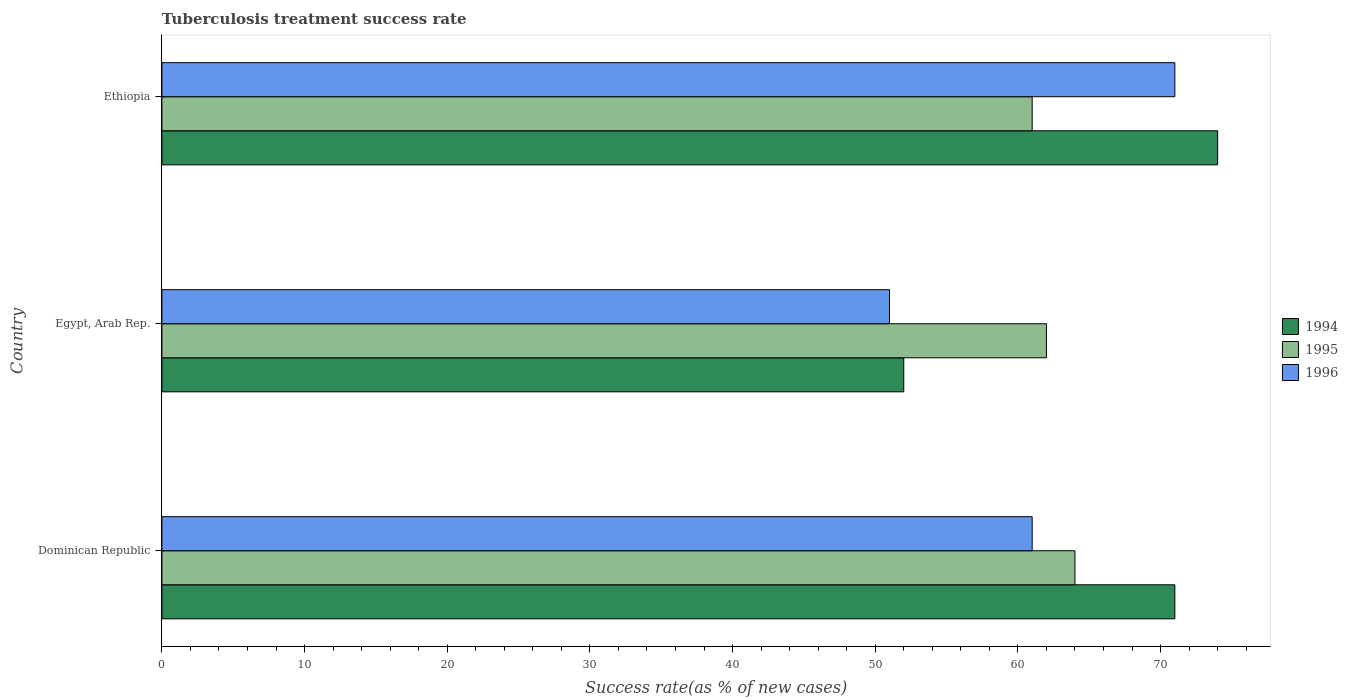How many different coloured bars are there?
Offer a very short reply. 3. How many groups of bars are there?
Offer a very short reply. 3. Are the number of bars on each tick of the Y-axis equal?
Your response must be concise. Yes. How many bars are there on the 3rd tick from the top?
Provide a succinct answer. 3. What is the label of the 1st group of bars from the top?
Give a very brief answer. Ethiopia. In how many cases, is the number of bars for a given country not equal to the number of legend labels?
Your response must be concise. 0. Across all countries, what is the maximum tuberculosis treatment success rate in 1994?
Offer a very short reply. 74. Across all countries, what is the minimum tuberculosis treatment success rate in 1996?
Provide a short and direct response. 51. In which country was the tuberculosis treatment success rate in 1995 maximum?
Make the answer very short. Dominican Republic. In which country was the tuberculosis treatment success rate in 1995 minimum?
Keep it short and to the point. Ethiopia. What is the total tuberculosis treatment success rate in 1995 in the graph?
Give a very brief answer. 187. What is the difference between the tuberculosis treatment success rate in 1994 in Ethiopia and the tuberculosis treatment success rate in 1995 in Egypt, Arab Rep.?
Your answer should be very brief. 12. What is the average tuberculosis treatment success rate in 1994 per country?
Your response must be concise. 65.67. What is the ratio of the tuberculosis treatment success rate in 1996 in Egypt, Arab Rep. to that in Ethiopia?
Your response must be concise. 0.72. Is the difference between the tuberculosis treatment success rate in 1995 in Dominican Republic and Ethiopia greater than the difference between the tuberculosis treatment success rate in 1996 in Dominican Republic and Ethiopia?
Your response must be concise. Yes. Is the sum of the tuberculosis treatment success rate in 1994 in Egypt, Arab Rep. and Ethiopia greater than the maximum tuberculosis treatment success rate in 1996 across all countries?
Provide a short and direct response. Yes. What does the 3rd bar from the bottom in Egypt, Arab Rep. represents?
Your response must be concise. 1996. Is it the case that in every country, the sum of the tuberculosis treatment success rate in 1995 and tuberculosis treatment success rate in 1996 is greater than the tuberculosis treatment success rate in 1994?
Offer a very short reply. Yes. How many countries are there in the graph?
Offer a terse response. 3. Are the values on the major ticks of X-axis written in scientific E-notation?
Provide a succinct answer. No. Does the graph contain any zero values?
Your response must be concise. No. How many legend labels are there?
Your response must be concise. 3. What is the title of the graph?
Provide a succinct answer. Tuberculosis treatment success rate. What is the label or title of the X-axis?
Make the answer very short. Success rate(as % of new cases). What is the label or title of the Y-axis?
Ensure brevity in your answer.  Country. What is the Success rate(as % of new cases) of 1995 in Egypt, Arab Rep.?
Offer a very short reply. 62. What is the Success rate(as % of new cases) of 1995 in Ethiopia?
Offer a terse response. 61. What is the Success rate(as % of new cases) in 1996 in Ethiopia?
Your response must be concise. 71. Across all countries, what is the maximum Success rate(as % of new cases) of 1995?
Your answer should be very brief. 64. Across all countries, what is the maximum Success rate(as % of new cases) in 1996?
Provide a succinct answer. 71. Across all countries, what is the minimum Success rate(as % of new cases) of 1995?
Provide a succinct answer. 61. Across all countries, what is the minimum Success rate(as % of new cases) in 1996?
Keep it short and to the point. 51. What is the total Success rate(as % of new cases) of 1994 in the graph?
Provide a succinct answer. 197. What is the total Success rate(as % of new cases) of 1995 in the graph?
Keep it short and to the point. 187. What is the total Success rate(as % of new cases) of 1996 in the graph?
Your response must be concise. 183. What is the difference between the Success rate(as % of new cases) of 1996 in Dominican Republic and that in Egypt, Arab Rep.?
Provide a short and direct response. 10. What is the difference between the Success rate(as % of new cases) of 1996 in Dominican Republic and that in Ethiopia?
Offer a very short reply. -10. What is the difference between the Success rate(as % of new cases) in 1994 in Egypt, Arab Rep. and that in Ethiopia?
Offer a very short reply. -22. What is the difference between the Success rate(as % of new cases) in 1995 in Egypt, Arab Rep. and that in Ethiopia?
Give a very brief answer. 1. What is the difference between the Success rate(as % of new cases) in 1996 in Egypt, Arab Rep. and that in Ethiopia?
Ensure brevity in your answer.  -20. What is the difference between the Success rate(as % of new cases) in 1994 in Dominican Republic and the Success rate(as % of new cases) in 1996 in Egypt, Arab Rep.?
Your response must be concise. 20. What is the difference between the Success rate(as % of new cases) in 1995 in Dominican Republic and the Success rate(as % of new cases) in 1996 in Egypt, Arab Rep.?
Ensure brevity in your answer.  13. What is the difference between the Success rate(as % of new cases) in 1994 in Dominican Republic and the Success rate(as % of new cases) in 1995 in Ethiopia?
Your answer should be compact. 10. What is the difference between the Success rate(as % of new cases) in 1994 in Egypt, Arab Rep. and the Success rate(as % of new cases) in 1995 in Ethiopia?
Your response must be concise. -9. What is the difference between the Success rate(as % of new cases) of 1995 in Egypt, Arab Rep. and the Success rate(as % of new cases) of 1996 in Ethiopia?
Your answer should be compact. -9. What is the average Success rate(as % of new cases) in 1994 per country?
Give a very brief answer. 65.67. What is the average Success rate(as % of new cases) in 1995 per country?
Offer a terse response. 62.33. What is the average Success rate(as % of new cases) in 1996 per country?
Your answer should be very brief. 61. What is the difference between the Success rate(as % of new cases) in 1994 and Success rate(as % of new cases) in 1996 in Dominican Republic?
Offer a very short reply. 10. What is the difference between the Success rate(as % of new cases) of 1994 and Success rate(as % of new cases) of 1995 in Egypt, Arab Rep.?
Your answer should be compact. -10. What is the difference between the Success rate(as % of new cases) in 1995 and Success rate(as % of new cases) in 1996 in Egypt, Arab Rep.?
Provide a succinct answer. 11. What is the difference between the Success rate(as % of new cases) in 1994 and Success rate(as % of new cases) in 1996 in Ethiopia?
Your answer should be compact. 3. What is the difference between the Success rate(as % of new cases) of 1995 and Success rate(as % of new cases) of 1996 in Ethiopia?
Offer a terse response. -10. What is the ratio of the Success rate(as % of new cases) of 1994 in Dominican Republic to that in Egypt, Arab Rep.?
Ensure brevity in your answer.  1.37. What is the ratio of the Success rate(as % of new cases) of 1995 in Dominican Republic to that in Egypt, Arab Rep.?
Keep it short and to the point. 1.03. What is the ratio of the Success rate(as % of new cases) of 1996 in Dominican Republic to that in Egypt, Arab Rep.?
Ensure brevity in your answer.  1.2. What is the ratio of the Success rate(as % of new cases) in 1994 in Dominican Republic to that in Ethiopia?
Your answer should be very brief. 0.96. What is the ratio of the Success rate(as % of new cases) of 1995 in Dominican Republic to that in Ethiopia?
Make the answer very short. 1.05. What is the ratio of the Success rate(as % of new cases) in 1996 in Dominican Republic to that in Ethiopia?
Provide a succinct answer. 0.86. What is the ratio of the Success rate(as % of new cases) of 1994 in Egypt, Arab Rep. to that in Ethiopia?
Provide a short and direct response. 0.7. What is the ratio of the Success rate(as % of new cases) of 1995 in Egypt, Arab Rep. to that in Ethiopia?
Ensure brevity in your answer.  1.02. What is the ratio of the Success rate(as % of new cases) of 1996 in Egypt, Arab Rep. to that in Ethiopia?
Make the answer very short. 0.72. What is the difference between the highest and the second highest Success rate(as % of new cases) in 1994?
Provide a short and direct response. 3. What is the difference between the highest and the second highest Success rate(as % of new cases) in 1995?
Keep it short and to the point. 2. What is the difference between the highest and the second highest Success rate(as % of new cases) in 1996?
Keep it short and to the point. 10. 